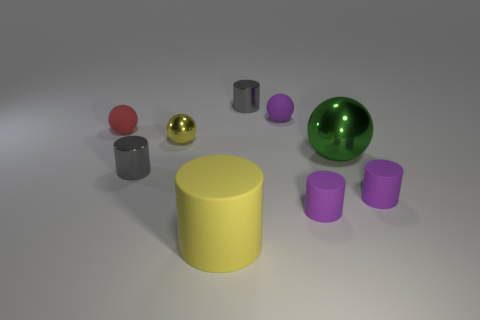Subtract all purple balls. How many balls are left? 3 Subtract all balls. How many objects are left? 5 Subtract 3 balls. How many balls are left? 1 Subtract all green spheres. How many spheres are left? 3 Add 7 big objects. How many big objects exist? 9 Subtract 1 yellow cylinders. How many objects are left? 8 Subtract all red cylinders. Subtract all brown spheres. How many cylinders are left? 5 Subtract all gray blocks. How many purple spheres are left? 1 Subtract all large yellow cylinders. Subtract all tiny matte objects. How many objects are left? 4 Add 2 small gray shiny cylinders. How many small gray shiny cylinders are left? 4 